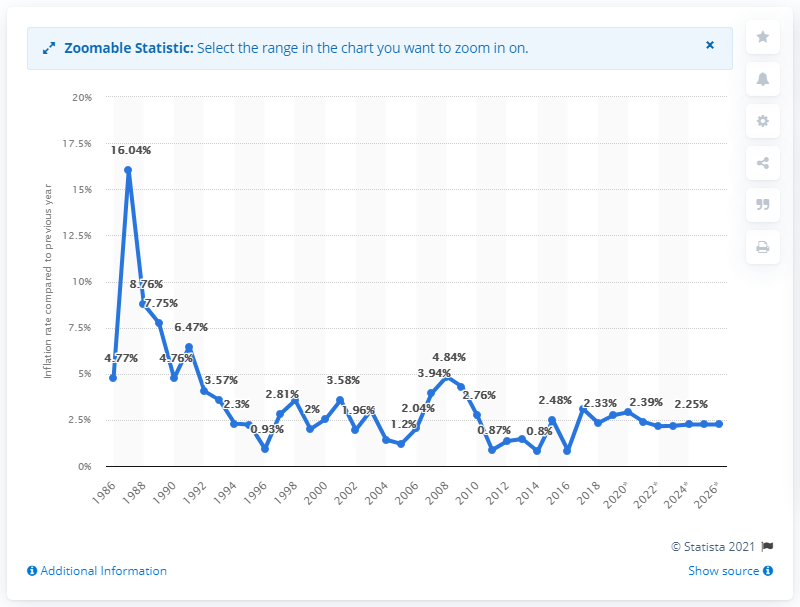Mention a couple of crucial points in this snapshot. The average inflation rate in Vanuatu was in 1986. 